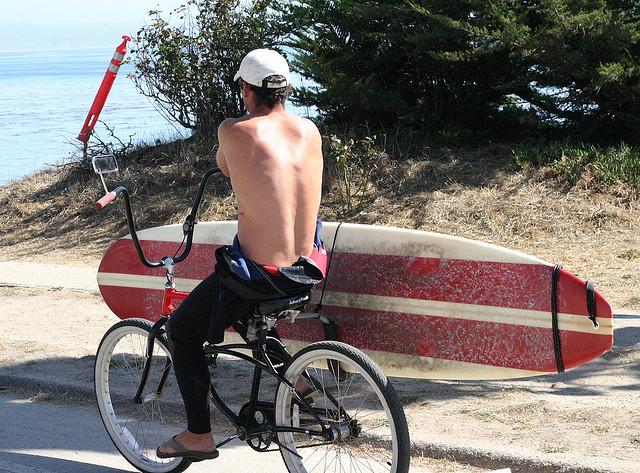Is he surfing?
Give a very brief answer. No. What is he riding?
Quick response, please. Bicycle. What type of footwear is the man wearing?
Write a very short answer. Flip flops. 